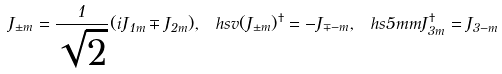<formula> <loc_0><loc_0><loc_500><loc_500>J _ { \pm m } = \frac { 1 } { \sqrt { 2 } } ( i J _ { 1 m } \mp J _ { 2 m } ) , \ h s v ( J _ { \pm m } ) ^ { \dagger } = - J _ { \mp - m } , \ h s { 5 m m } J _ { 3 m } ^ { \dagger } = J _ { 3 - m }</formula> 